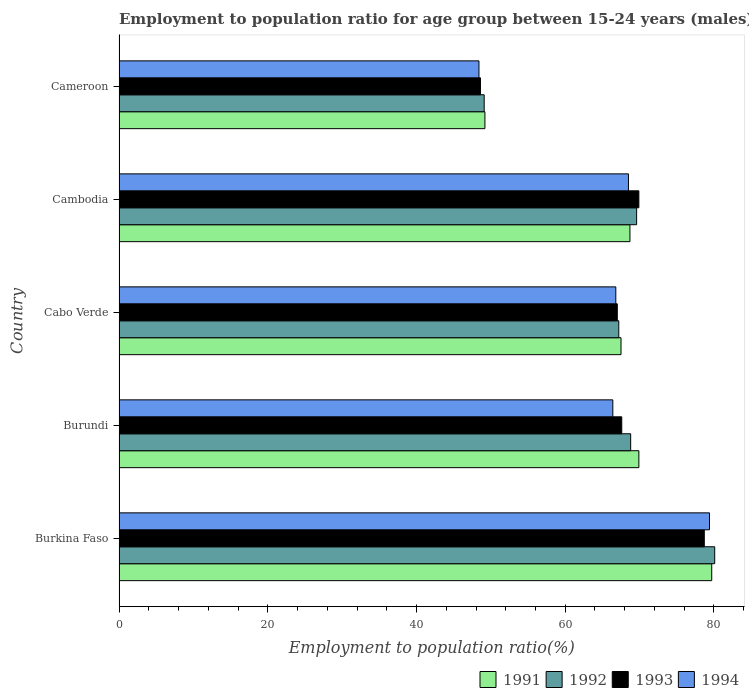How many different coloured bars are there?
Your response must be concise. 4. How many groups of bars are there?
Make the answer very short. 5. Are the number of bars on each tick of the Y-axis equal?
Offer a terse response. Yes. What is the label of the 4th group of bars from the top?
Make the answer very short. Burundi. What is the employment to population ratio in 1991 in Cameroon?
Your answer should be compact. 49.2. Across all countries, what is the maximum employment to population ratio in 1994?
Offer a very short reply. 79.4. Across all countries, what is the minimum employment to population ratio in 1994?
Provide a short and direct response. 48.4. In which country was the employment to population ratio in 1994 maximum?
Give a very brief answer. Burkina Faso. In which country was the employment to population ratio in 1992 minimum?
Your response must be concise. Cameroon. What is the total employment to population ratio in 1991 in the graph?
Ensure brevity in your answer.  335. What is the difference between the employment to population ratio in 1994 in Burkina Faso and that in Cameroon?
Ensure brevity in your answer.  31. What is the difference between the employment to population ratio in 1993 in Cambodia and the employment to population ratio in 1991 in Cameroon?
Offer a very short reply. 20.7. What is the average employment to population ratio in 1992 per country?
Provide a short and direct response. 66.96. What is the difference between the employment to population ratio in 1991 and employment to population ratio in 1993 in Burundi?
Ensure brevity in your answer.  2.3. In how many countries, is the employment to population ratio in 1992 greater than 20 %?
Offer a very short reply. 5. What is the ratio of the employment to population ratio in 1993 in Cambodia to that in Cameroon?
Offer a terse response. 1.44. Is the difference between the employment to population ratio in 1991 in Burundi and Cambodia greater than the difference between the employment to population ratio in 1993 in Burundi and Cambodia?
Ensure brevity in your answer.  Yes. What is the difference between the highest and the lowest employment to population ratio in 1994?
Keep it short and to the point. 31. In how many countries, is the employment to population ratio in 1994 greater than the average employment to population ratio in 1994 taken over all countries?
Ensure brevity in your answer.  4. What does the 1st bar from the top in Burundi represents?
Make the answer very short. 1994. How many countries are there in the graph?
Offer a terse response. 5. Are the values on the major ticks of X-axis written in scientific E-notation?
Ensure brevity in your answer.  No. Does the graph contain any zero values?
Provide a succinct answer. No. Does the graph contain grids?
Keep it short and to the point. No. Where does the legend appear in the graph?
Provide a succinct answer. Bottom right. How many legend labels are there?
Keep it short and to the point. 4. What is the title of the graph?
Offer a very short reply. Employment to population ratio for age group between 15-24 years (males). What is the label or title of the X-axis?
Ensure brevity in your answer.  Employment to population ratio(%). What is the label or title of the Y-axis?
Offer a terse response. Country. What is the Employment to population ratio(%) of 1991 in Burkina Faso?
Ensure brevity in your answer.  79.7. What is the Employment to population ratio(%) in 1992 in Burkina Faso?
Your response must be concise. 80.1. What is the Employment to population ratio(%) of 1993 in Burkina Faso?
Your answer should be compact. 78.7. What is the Employment to population ratio(%) of 1994 in Burkina Faso?
Provide a succinct answer. 79.4. What is the Employment to population ratio(%) of 1991 in Burundi?
Give a very brief answer. 69.9. What is the Employment to population ratio(%) in 1992 in Burundi?
Provide a short and direct response. 68.8. What is the Employment to population ratio(%) of 1993 in Burundi?
Ensure brevity in your answer.  67.6. What is the Employment to population ratio(%) in 1994 in Burundi?
Provide a short and direct response. 66.4. What is the Employment to population ratio(%) in 1991 in Cabo Verde?
Provide a succinct answer. 67.5. What is the Employment to population ratio(%) in 1992 in Cabo Verde?
Offer a terse response. 67.2. What is the Employment to population ratio(%) in 1994 in Cabo Verde?
Offer a very short reply. 66.8. What is the Employment to population ratio(%) of 1991 in Cambodia?
Provide a short and direct response. 68.7. What is the Employment to population ratio(%) in 1992 in Cambodia?
Ensure brevity in your answer.  69.6. What is the Employment to population ratio(%) in 1993 in Cambodia?
Keep it short and to the point. 69.9. What is the Employment to population ratio(%) in 1994 in Cambodia?
Make the answer very short. 68.5. What is the Employment to population ratio(%) of 1991 in Cameroon?
Your answer should be very brief. 49.2. What is the Employment to population ratio(%) in 1992 in Cameroon?
Provide a succinct answer. 49.1. What is the Employment to population ratio(%) of 1993 in Cameroon?
Your response must be concise. 48.6. What is the Employment to population ratio(%) of 1994 in Cameroon?
Your answer should be compact. 48.4. Across all countries, what is the maximum Employment to population ratio(%) of 1991?
Keep it short and to the point. 79.7. Across all countries, what is the maximum Employment to population ratio(%) of 1992?
Your answer should be very brief. 80.1. Across all countries, what is the maximum Employment to population ratio(%) in 1993?
Offer a terse response. 78.7. Across all countries, what is the maximum Employment to population ratio(%) in 1994?
Give a very brief answer. 79.4. Across all countries, what is the minimum Employment to population ratio(%) of 1991?
Make the answer very short. 49.2. Across all countries, what is the minimum Employment to population ratio(%) of 1992?
Ensure brevity in your answer.  49.1. Across all countries, what is the minimum Employment to population ratio(%) in 1993?
Offer a terse response. 48.6. Across all countries, what is the minimum Employment to population ratio(%) of 1994?
Make the answer very short. 48.4. What is the total Employment to population ratio(%) of 1991 in the graph?
Offer a very short reply. 335. What is the total Employment to population ratio(%) in 1992 in the graph?
Offer a terse response. 334.8. What is the total Employment to population ratio(%) of 1993 in the graph?
Provide a succinct answer. 331.8. What is the total Employment to population ratio(%) of 1994 in the graph?
Your answer should be compact. 329.5. What is the difference between the Employment to population ratio(%) in 1991 in Burkina Faso and that in Burundi?
Your response must be concise. 9.8. What is the difference between the Employment to population ratio(%) in 1992 in Burkina Faso and that in Burundi?
Your answer should be compact. 11.3. What is the difference between the Employment to population ratio(%) in 1994 in Burkina Faso and that in Burundi?
Provide a short and direct response. 13. What is the difference between the Employment to population ratio(%) of 1993 in Burkina Faso and that in Cabo Verde?
Your response must be concise. 11.7. What is the difference between the Employment to population ratio(%) of 1994 in Burkina Faso and that in Cabo Verde?
Make the answer very short. 12.6. What is the difference between the Employment to population ratio(%) in 1994 in Burkina Faso and that in Cambodia?
Offer a terse response. 10.9. What is the difference between the Employment to population ratio(%) of 1991 in Burkina Faso and that in Cameroon?
Make the answer very short. 30.5. What is the difference between the Employment to population ratio(%) in 1993 in Burkina Faso and that in Cameroon?
Your answer should be very brief. 30.1. What is the difference between the Employment to population ratio(%) in 1994 in Burkina Faso and that in Cameroon?
Keep it short and to the point. 31. What is the difference between the Employment to population ratio(%) in 1992 in Burundi and that in Cabo Verde?
Ensure brevity in your answer.  1.6. What is the difference between the Employment to population ratio(%) of 1993 in Burundi and that in Cabo Verde?
Give a very brief answer. 0.6. What is the difference between the Employment to population ratio(%) of 1994 in Burundi and that in Cabo Verde?
Your response must be concise. -0.4. What is the difference between the Employment to population ratio(%) of 1991 in Burundi and that in Cambodia?
Your answer should be very brief. 1.2. What is the difference between the Employment to population ratio(%) in 1994 in Burundi and that in Cambodia?
Provide a succinct answer. -2.1. What is the difference between the Employment to population ratio(%) of 1991 in Burundi and that in Cameroon?
Ensure brevity in your answer.  20.7. What is the difference between the Employment to population ratio(%) of 1992 in Burundi and that in Cameroon?
Ensure brevity in your answer.  19.7. What is the difference between the Employment to population ratio(%) in 1994 in Burundi and that in Cameroon?
Give a very brief answer. 18. What is the difference between the Employment to population ratio(%) of 1991 in Cabo Verde and that in Cambodia?
Give a very brief answer. -1.2. What is the difference between the Employment to population ratio(%) of 1992 in Cabo Verde and that in Cambodia?
Your answer should be compact. -2.4. What is the difference between the Employment to population ratio(%) in 1993 in Cabo Verde and that in Cambodia?
Your answer should be very brief. -2.9. What is the difference between the Employment to population ratio(%) in 1994 in Cabo Verde and that in Cambodia?
Provide a short and direct response. -1.7. What is the difference between the Employment to population ratio(%) of 1991 in Cabo Verde and that in Cameroon?
Ensure brevity in your answer.  18.3. What is the difference between the Employment to population ratio(%) in 1991 in Cambodia and that in Cameroon?
Offer a terse response. 19.5. What is the difference between the Employment to population ratio(%) of 1993 in Cambodia and that in Cameroon?
Provide a succinct answer. 21.3. What is the difference between the Employment to population ratio(%) of 1994 in Cambodia and that in Cameroon?
Your answer should be compact. 20.1. What is the difference between the Employment to population ratio(%) of 1991 in Burkina Faso and the Employment to population ratio(%) of 1993 in Burundi?
Ensure brevity in your answer.  12.1. What is the difference between the Employment to population ratio(%) of 1991 in Burkina Faso and the Employment to population ratio(%) of 1994 in Burundi?
Your answer should be very brief. 13.3. What is the difference between the Employment to population ratio(%) in 1992 in Burkina Faso and the Employment to population ratio(%) in 1993 in Burundi?
Provide a short and direct response. 12.5. What is the difference between the Employment to population ratio(%) in 1993 in Burkina Faso and the Employment to population ratio(%) in 1994 in Burundi?
Offer a terse response. 12.3. What is the difference between the Employment to population ratio(%) of 1991 in Burkina Faso and the Employment to population ratio(%) of 1993 in Cabo Verde?
Your response must be concise. 12.7. What is the difference between the Employment to population ratio(%) in 1991 in Burkina Faso and the Employment to population ratio(%) in 1993 in Cambodia?
Provide a short and direct response. 9.8. What is the difference between the Employment to population ratio(%) in 1993 in Burkina Faso and the Employment to population ratio(%) in 1994 in Cambodia?
Your answer should be compact. 10.2. What is the difference between the Employment to population ratio(%) of 1991 in Burkina Faso and the Employment to population ratio(%) of 1992 in Cameroon?
Provide a succinct answer. 30.6. What is the difference between the Employment to population ratio(%) in 1991 in Burkina Faso and the Employment to population ratio(%) in 1993 in Cameroon?
Ensure brevity in your answer.  31.1. What is the difference between the Employment to population ratio(%) of 1991 in Burkina Faso and the Employment to population ratio(%) of 1994 in Cameroon?
Your response must be concise. 31.3. What is the difference between the Employment to population ratio(%) of 1992 in Burkina Faso and the Employment to population ratio(%) of 1993 in Cameroon?
Provide a short and direct response. 31.5. What is the difference between the Employment to population ratio(%) of 1992 in Burkina Faso and the Employment to population ratio(%) of 1994 in Cameroon?
Your answer should be very brief. 31.7. What is the difference between the Employment to population ratio(%) in 1993 in Burkina Faso and the Employment to population ratio(%) in 1994 in Cameroon?
Offer a very short reply. 30.3. What is the difference between the Employment to population ratio(%) in 1993 in Burundi and the Employment to population ratio(%) in 1994 in Cabo Verde?
Provide a succinct answer. 0.8. What is the difference between the Employment to population ratio(%) of 1991 in Burundi and the Employment to population ratio(%) of 1993 in Cambodia?
Offer a terse response. 0. What is the difference between the Employment to population ratio(%) of 1991 in Burundi and the Employment to population ratio(%) of 1994 in Cambodia?
Provide a succinct answer. 1.4. What is the difference between the Employment to population ratio(%) in 1993 in Burundi and the Employment to population ratio(%) in 1994 in Cambodia?
Your answer should be very brief. -0.9. What is the difference between the Employment to population ratio(%) of 1991 in Burundi and the Employment to population ratio(%) of 1992 in Cameroon?
Your response must be concise. 20.8. What is the difference between the Employment to population ratio(%) in 1991 in Burundi and the Employment to population ratio(%) in 1993 in Cameroon?
Give a very brief answer. 21.3. What is the difference between the Employment to population ratio(%) of 1991 in Burundi and the Employment to population ratio(%) of 1994 in Cameroon?
Ensure brevity in your answer.  21.5. What is the difference between the Employment to population ratio(%) of 1992 in Burundi and the Employment to population ratio(%) of 1993 in Cameroon?
Ensure brevity in your answer.  20.2. What is the difference between the Employment to population ratio(%) of 1992 in Burundi and the Employment to population ratio(%) of 1994 in Cameroon?
Keep it short and to the point. 20.4. What is the difference between the Employment to population ratio(%) of 1991 in Cabo Verde and the Employment to population ratio(%) of 1994 in Cambodia?
Offer a terse response. -1. What is the difference between the Employment to population ratio(%) in 1992 in Cabo Verde and the Employment to population ratio(%) in 1993 in Cambodia?
Provide a succinct answer. -2.7. What is the difference between the Employment to population ratio(%) in 1991 in Cabo Verde and the Employment to population ratio(%) in 1993 in Cameroon?
Your response must be concise. 18.9. What is the difference between the Employment to population ratio(%) in 1992 in Cabo Verde and the Employment to population ratio(%) in 1993 in Cameroon?
Keep it short and to the point. 18.6. What is the difference between the Employment to population ratio(%) of 1993 in Cabo Verde and the Employment to population ratio(%) of 1994 in Cameroon?
Provide a short and direct response. 18.6. What is the difference between the Employment to population ratio(%) of 1991 in Cambodia and the Employment to population ratio(%) of 1992 in Cameroon?
Ensure brevity in your answer.  19.6. What is the difference between the Employment to population ratio(%) in 1991 in Cambodia and the Employment to population ratio(%) in 1993 in Cameroon?
Your answer should be very brief. 20.1. What is the difference between the Employment to population ratio(%) of 1991 in Cambodia and the Employment to population ratio(%) of 1994 in Cameroon?
Make the answer very short. 20.3. What is the difference between the Employment to population ratio(%) in 1992 in Cambodia and the Employment to population ratio(%) in 1993 in Cameroon?
Your answer should be very brief. 21. What is the difference between the Employment to population ratio(%) of 1992 in Cambodia and the Employment to population ratio(%) of 1994 in Cameroon?
Provide a short and direct response. 21.2. What is the average Employment to population ratio(%) of 1991 per country?
Your answer should be compact. 67. What is the average Employment to population ratio(%) in 1992 per country?
Your answer should be compact. 66.96. What is the average Employment to population ratio(%) of 1993 per country?
Provide a succinct answer. 66.36. What is the average Employment to population ratio(%) in 1994 per country?
Provide a short and direct response. 65.9. What is the difference between the Employment to population ratio(%) in 1991 and Employment to population ratio(%) in 1992 in Burkina Faso?
Your answer should be very brief. -0.4. What is the difference between the Employment to population ratio(%) in 1991 and Employment to population ratio(%) in 1994 in Burkina Faso?
Offer a very short reply. 0.3. What is the difference between the Employment to population ratio(%) of 1992 and Employment to population ratio(%) of 1993 in Burkina Faso?
Provide a succinct answer. 1.4. What is the difference between the Employment to population ratio(%) in 1992 and Employment to population ratio(%) in 1994 in Burkina Faso?
Give a very brief answer. 0.7. What is the difference between the Employment to population ratio(%) in 1991 and Employment to population ratio(%) in 1993 in Burundi?
Offer a terse response. 2.3. What is the difference between the Employment to population ratio(%) in 1992 and Employment to population ratio(%) in 1993 in Burundi?
Your response must be concise. 1.2. What is the difference between the Employment to population ratio(%) of 1992 and Employment to population ratio(%) of 1994 in Burundi?
Your response must be concise. 2.4. What is the difference between the Employment to population ratio(%) of 1993 and Employment to population ratio(%) of 1994 in Burundi?
Provide a short and direct response. 1.2. What is the difference between the Employment to population ratio(%) in 1991 and Employment to population ratio(%) in 1994 in Cabo Verde?
Provide a succinct answer. 0.7. What is the difference between the Employment to population ratio(%) in 1992 and Employment to population ratio(%) in 1993 in Cabo Verde?
Your answer should be compact. 0.2. What is the difference between the Employment to population ratio(%) of 1992 and Employment to population ratio(%) of 1994 in Cabo Verde?
Offer a terse response. 0.4. What is the difference between the Employment to population ratio(%) in 1993 and Employment to population ratio(%) in 1994 in Cabo Verde?
Your answer should be very brief. 0.2. What is the difference between the Employment to population ratio(%) of 1991 and Employment to population ratio(%) of 1992 in Cambodia?
Make the answer very short. -0.9. What is the difference between the Employment to population ratio(%) in 1991 and Employment to population ratio(%) in 1994 in Cambodia?
Your response must be concise. 0.2. What is the difference between the Employment to population ratio(%) of 1992 and Employment to population ratio(%) of 1994 in Cambodia?
Provide a succinct answer. 1.1. What is the difference between the Employment to population ratio(%) of 1993 and Employment to population ratio(%) of 1994 in Cambodia?
Offer a very short reply. 1.4. What is the difference between the Employment to population ratio(%) of 1991 and Employment to population ratio(%) of 1992 in Cameroon?
Keep it short and to the point. 0.1. What is the difference between the Employment to population ratio(%) of 1991 and Employment to population ratio(%) of 1993 in Cameroon?
Provide a short and direct response. 0.6. What is the difference between the Employment to population ratio(%) in 1992 and Employment to population ratio(%) in 1993 in Cameroon?
Give a very brief answer. 0.5. What is the difference between the Employment to population ratio(%) of 1993 and Employment to population ratio(%) of 1994 in Cameroon?
Your answer should be very brief. 0.2. What is the ratio of the Employment to population ratio(%) in 1991 in Burkina Faso to that in Burundi?
Offer a very short reply. 1.14. What is the ratio of the Employment to population ratio(%) in 1992 in Burkina Faso to that in Burundi?
Give a very brief answer. 1.16. What is the ratio of the Employment to population ratio(%) of 1993 in Burkina Faso to that in Burundi?
Ensure brevity in your answer.  1.16. What is the ratio of the Employment to population ratio(%) in 1994 in Burkina Faso to that in Burundi?
Your answer should be compact. 1.2. What is the ratio of the Employment to population ratio(%) in 1991 in Burkina Faso to that in Cabo Verde?
Your answer should be compact. 1.18. What is the ratio of the Employment to population ratio(%) in 1992 in Burkina Faso to that in Cabo Verde?
Ensure brevity in your answer.  1.19. What is the ratio of the Employment to population ratio(%) in 1993 in Burkina Faso to that in Cabo Verde?
Provide a succinct answer. 1.17. What is the ratio of the Employment to population ratio(%) in 1994 in Burkina Faso to that in Cabo Verde?
Ensure brevity in your answer.  1.19. What is the ratio of the Employment to population ratio(%) in 1991 in Burkina Faso to that in Cambodia?
Ensure brevity in your answer.  1.16. What is the ratio of the Employment to population ratio(%) in 1992 in Burkina Faso to that in Cambodia?
Offer a very short reply. 1.15. What is the ratio of the Employment to population ratio(%) of 1993 in Burkina Faso to that in Cambodia?
Ensure brevity in your answer.  1.13. What is the ratio of the Employment to population ratio(%) of 1994 in Burkina Faso to that in Cambodia?
Give a very brief answer. 1.16. What is the ratio of the Employment to population ratio(%) in 1991 in Burkina Faso to that in Cameroon?
Your answer should be compact. 1.62. What is the ratio of the Employment to population ratio(%) in 1992 in Burkina Faso to that in Cameroon?
Provide a succinct answer. 1.63. What is the ratio of the Employment to population ratio(%) in 1993 in Burkina Faso to that in Cameroon?
Provide a succinct answer. 1.62. What is the ratio of the Employment to population ratio(%) in 1994 in Burkina Faso to that in Cameroon?
Provide a succinct answer. 1.64. What is the ratio of the Employment to population ratio(%) of 1991 in Burundi to that in Cabo Verde?
Keep it short and to the point. 1.04. What is the ratio of the Employment to population ratio(%) of 1992 in Burundi to that in Cabo Verde?
Provide a succinct answer. 1.02. What is the ratio of the Employment to population ratio(%) in 1993 in Burundi to that in Cabo Verde?
Offer a very short reply. 1.01. What is the ratio of the Employment to population ratio(%) of 1994 in Burundi to that in Cabo Verde?
Ensure brevity in your answer.  0.99. What is the ratio of the Employment to population ratio(%) of 1991 in Burundi to that in Cambodia?
Provide a short and direct response. 1.02. What is the ratio of the Employment to population ratio(%) in 1993 in Burundi to that in Cambodia?
Provide a short and direct response. 0.97. What is the ratio of the Employment to population ratio(%) of 1994 in Burundi to that in Cambodia?
Your answer should be very brief. 0.97. What is the ratio of the Employment to population ratio(%) of 1991 in Burundi to that in Cameroon?
Your answer should be very brief. 1.42. What is the ratio of the Employment to population ratio(%) in 1992 in Burundi to that in Cameroon?
Give a very brief answer. 1.4. What is the ratio of the Employment to population ratio(%) in 1993 in Burundi to that in Cameroon?
Provide a short and direct response. 1.39. What is the ratio of the Employment to population ratio(%) of 1994 in Burundi to that in Cameroon?
Your answer should be compact. 1.37. What is the ratio of the Employment to population ratio(%) in 1991 in Cabo Verde to that in Cambodia?
Your response must be concise. 0.98. What is the ratio of the Employment to population ratio(%) in 1992 in Cabo Verde to that in Cambodia?
Ensure brevity in your answer.  0.97. What is the ratio of the Employment to population ratio(%) in 1993 in Cabo Verde to that in Cambodia?
Keep it short and to the point. 0.96. What is the ratio of the Employment to population ratio(%) in 1994 in Cabo Verde to that in Cambodia?
Your answer should be very brief. 0.98. What is the ratio of the Employment to population ratio(%) of 1991 in Cabo Verde to that in Cameroon?
Keep it short and to the point. 1.37. What is the ratio of the Employment to population ratio(%) in 1992 in Cabo Verde to that in Cameroon?
Offer a very short reply. 1.37. What is the ratio of the Employment to population ratio(%) in 1993 in Cabo Verde to that in Cameroon?
Keep it short and to the point. 1.38. What is the ratio of the Employment to population ratio(%) of 1994 in Cabo Verde to that in Cameroon?
Make the answer very short. 1.38. What is the ratio of the Employment to population ratio(%) of 1991 in Cambodia to that in Cameroon?
Your answer should be compact. 1.4. What is the ratio of the Employment to population ratio(%) in 1992 in Cambodia to that in Cameroon?
Offer a very short reply. 1.42. What is the ratio of the Employment to population ratio(%) of 1993 in Cambodia to that in Cameroon?
Your answer should be compact. 1.44. What is the ratio of the Employment to population ratio(%) of 1994 in Cambodia to that in Cameroon?
Your answer should be very brief. 1.42. What is the difference between the highest and the second highest Employment to population ratio(%) of 1991?
Your answer should be very brief. 9.8. What is the difference between the highest and the second highest Employment to population ratio(%) in 1992?
Your answer should be very brief. 10.5. What is the difference between the highest and the second highest Employment to population ratio(%) of 1993?
Provide a short and direct response. 8.8. What is the difference between the highest and the second highest Employment to population ratio(%) of 1994?
Provide a succinct answer. 10.9. What is the difference between the highest and the lowest Employment to population ratio(%) in 1991?
Keep it short and to the point. 30.5. What is the difference between the highest and the lowest Employment to population ratio(%) in 1993?
Make the answer very short. 30.1. 